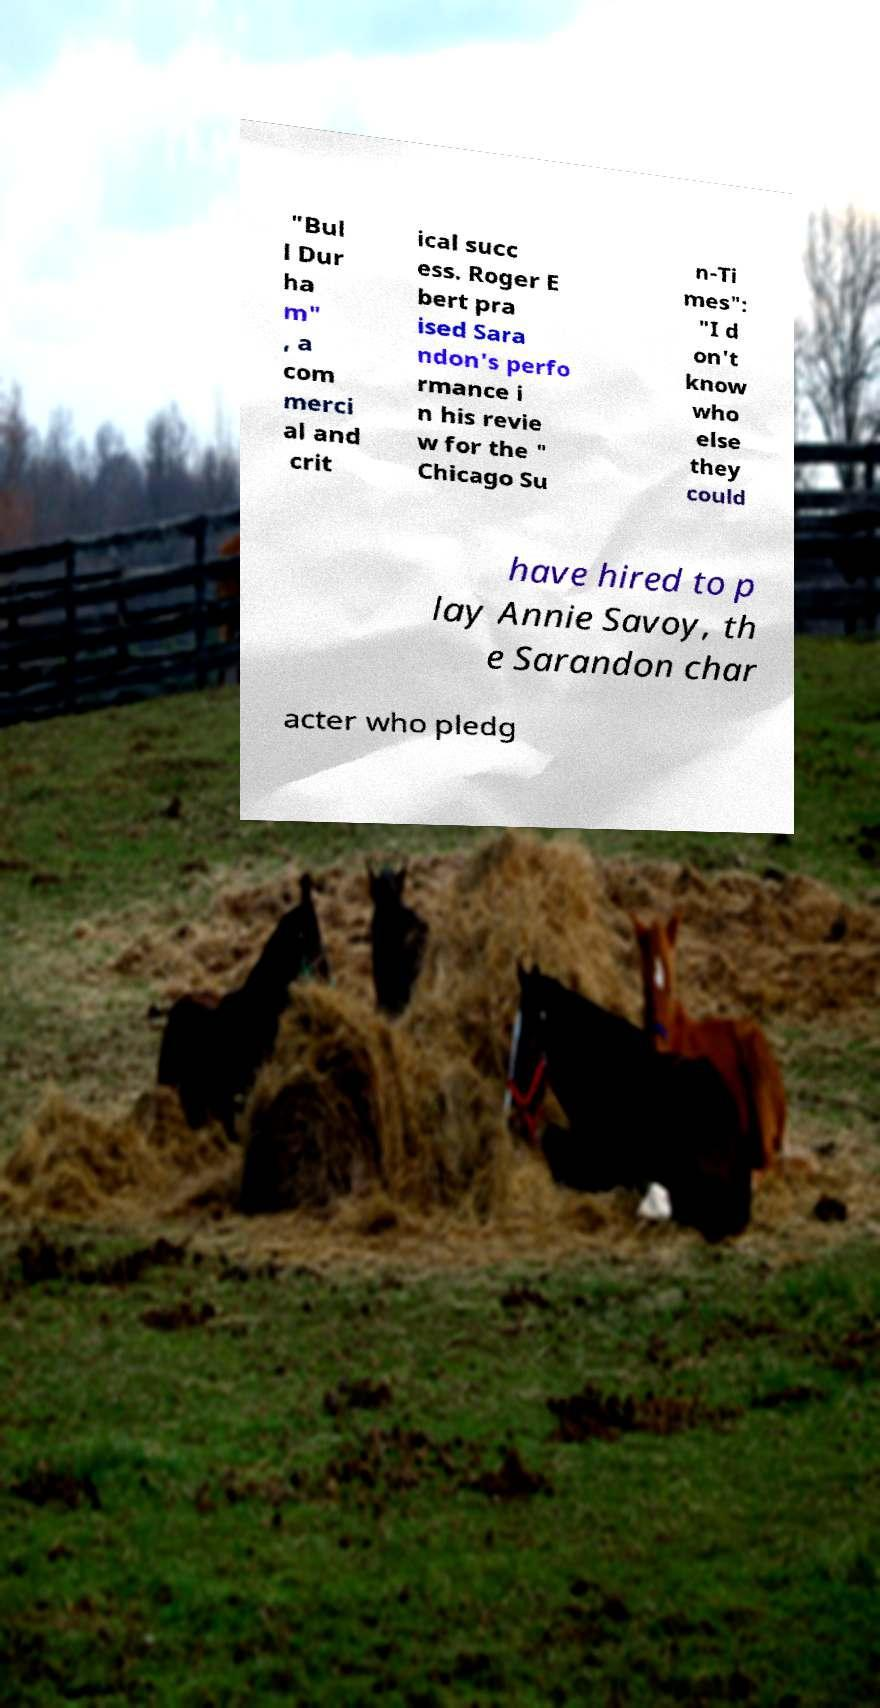There's text embedded in this image that I need extracted. Can you transcribe it verbatim? "Bul l Dur ha m" , a com merci al and crit ical succ ess. Roger E bert pra ised Sara ndon's perfo rmance i n his revie w for the " Chicago Su n-Ti mes": "I d on't know who else they could have hired to p lay Annie Savoy, th e Sarandon char acter who pledg 